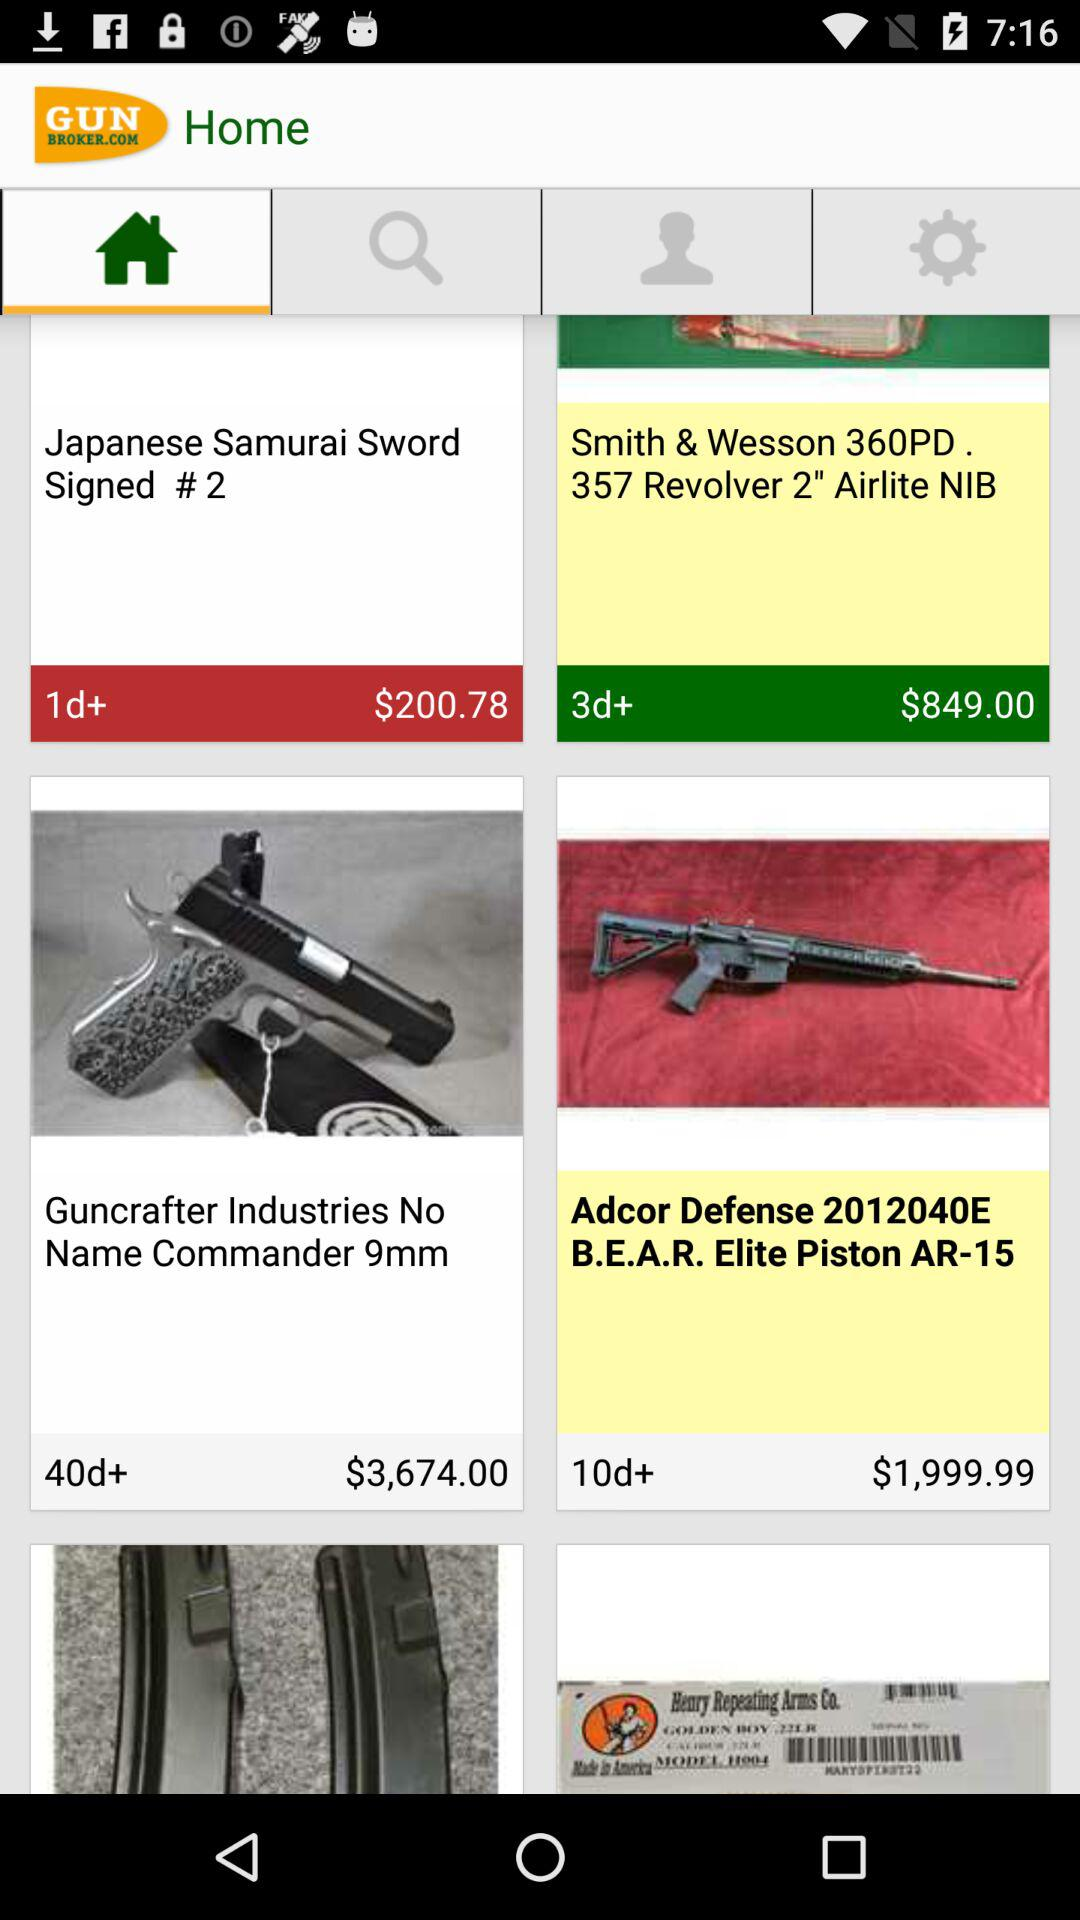Which item has a price of $200.78? The item is "Japanese Samurai Sword Signed # 2". 